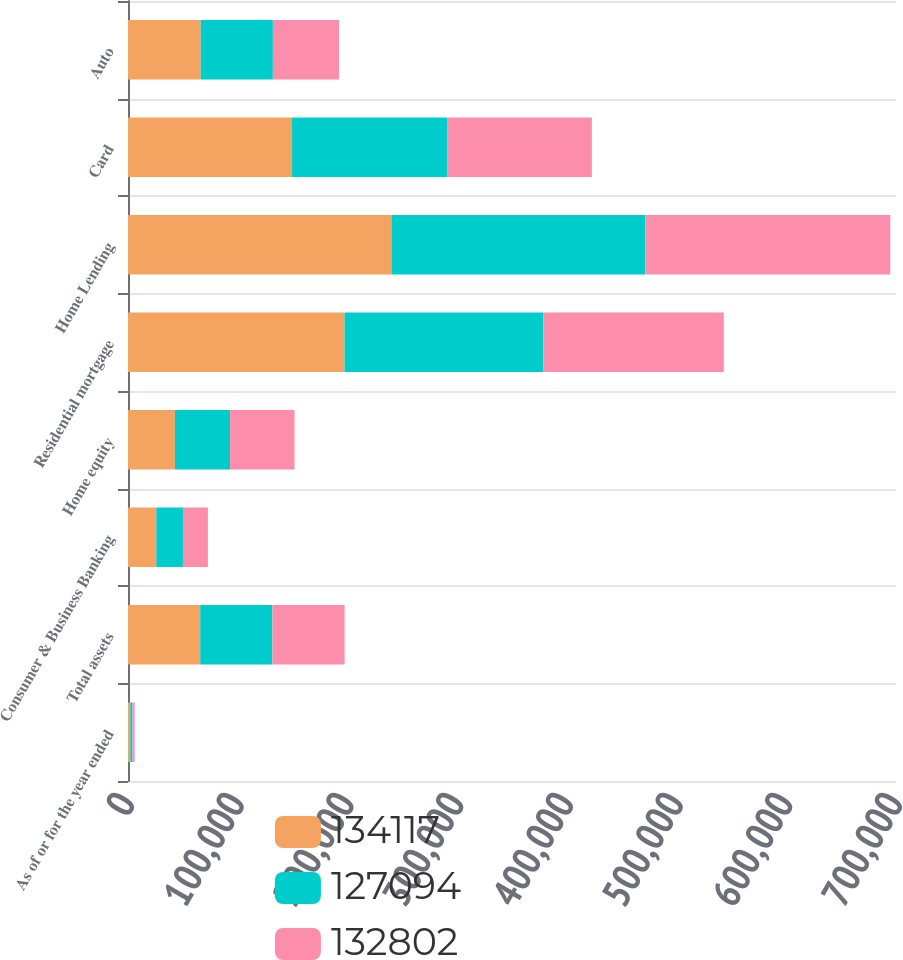Convert chart. <chart><loc_0><loc_0><loc_500><loc_500><stacked_bar_chart><ecel><fcel>As of or for the year ended<fcel>Total assets<fcel>Consumer & Business Banking<fcel>Home equity<fcel>Residential mortgage<fcel>Home Lending<fcel>Card<fcel>Auto<nl><fcel>134117<fcel>2017<fcel>65814<fcel>25789<fcel>42751<fcel>197339<fcel>240090<fcel>149511<fcel>66242<nl><fcel>127094<fcel>2016<fcel>65814<fcel>24307<fcel>50296<fcel>181196<fcel>231492<fcel>141816<fcel>65814<nl><fcel>132802<fcel>2015<fcel>65814<fcel>22730<fcel>58734<fcel>164500<fcel>223234<fcel>131463<fcel>60255<nl></chart> 